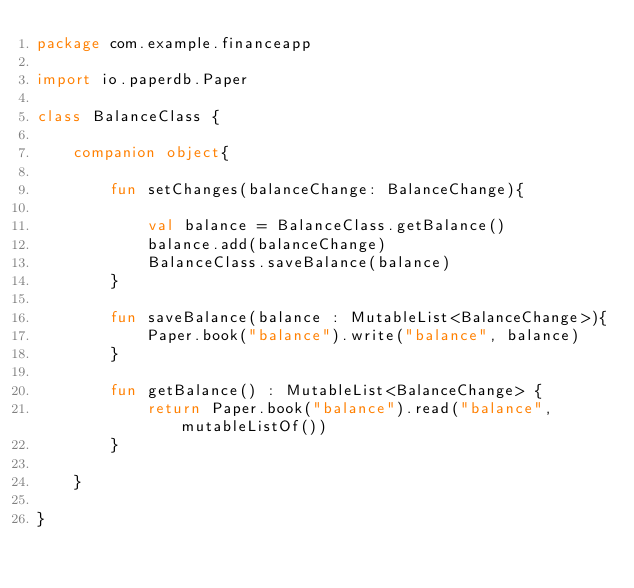Convert code to text. <code><loc_0><loc_0><loc_500><loc_500><_Kotlin_>package com.example.financeapp

import io.paperdb.Paper

class BalanceClass {

    companion object{

        fun setChanges(balanceChange: BalanceChange){

            val balance = BalanceClass.getBalance()
            balance.add(balanceChange)
            BalanceClass.saveBalance(balance)
        }

        fun saveBalance(balance : MutableList<BalanceChange>){
            Paper.book("balance").write("balance", balance)
        }

        fun getBalance() : MutableList<BalanceChange> {
            return Paper.book("balance").read("balance", mutableListOf())
        }

    }

}</code> 